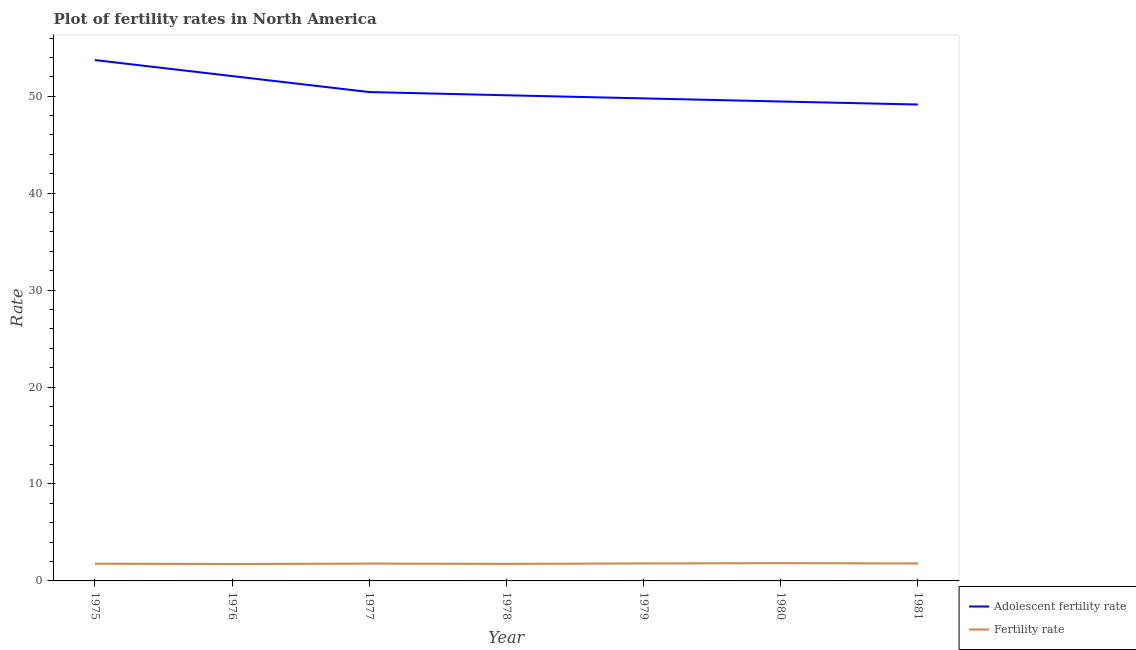Is the number of lines equal to the number of legend labels?
Offer a very short reply. Yes. What is the adolescent fertility rate in 1977?
Offer a terse response. 50.43. Across all years, what is the maximum adolescent fertility rate?
Offer a terse response. 53.72. Across all years, what is the minimum fertility rate?
Provide a short and direct response. 1.74. In which year was the adolescent fertility rate minimum?
Your response must be concise. 1981. What is the total fertility rate in the graph?
Offer a terse response. 12.51. What is the difference between the adolescent fertility rate in 1976 and that in 1977?
Provide a short and direct response. 1.65. What is the difference between the adolescent fertility rate in 1975 and the fertility rate in 1977?
Offer a terse response. 51.93. What is the average fertility rate per year?
Your response must be concise. 1.79. In the year 1981, what is the difference between the adolescent fertility rate and fertility rate?
Provide a short and direct response. 47.34. In how many years, is the adolescent fertility rate greater than 8?
Keep it short and to the point. 7. What is the ratio of the adolescent fertility rate in 1978 to that in 1979?
Offer a very short reply. 1.01. Is the difference between the adolescent fertility rate in 1978 and 1979 greater than the difference between the fertility rate in 1978 and 1979?
Keep it short and to the point. Yes. What is the difference between the highest and the second highest fertility rate?
Ensure brevity in your answer.  0.03. What is the difference between the highest and the lowest fertility rate?
Your response must be concise. 0.09. How many lines are there?
Give a very brief answer. 2. What is the difference between two consecutive major ticks on the Y-axis?
Your response must be concise. 10. Are the values on the major ticks of Y-axis written in scientific E-notation?
Offer a terse response. No. What is the title of the graph?
Keep it short and to the point. Plot of fertility rates in North America. Does "Register a property" appear as one of the legend labels in the graph?
Keep it short and to the point. No. What is the label or title of the X-axis?
Provide a short and direct response. Year. What is the label or title of the Y-axis?
Your answer should be very brief. Rate. What is the Rate of Adolescent fertility rate in 1975?
Ensure brevity in your answer.  53.72. What is the Rate of Fertility rate in 1975?
Give a very brief answer. 1.78. What is the Rate in Adolescent fertility rate in 1976?
Your answer should be very brief. 52.07. What is the Rate in Fertility rate in 1976?
Offer a very short reply. 1.74. What is the Rate in Adolescent fertility rate in 1977?
Make the answer very short. 50.43. What is the Rate of Fertility rate in 1977?
Offer a terse response. 1.79. What is the Rate of Adolescent fertility rate in 1978?
Keep it short and to the point. 50.09. What is the Rate in Fertility rate in 1978?
Keep it short and to the point. 1.76. What is the Rate in Adolescent fertility rate in 1979?
Ensure brevity in your answer.  49.77. What is the Rate of Fertility rate in 1979?
Provide a succinct answer. 1.8. What is the Rate of Adolescent fertility rate in 1980?
Your response must be concise. 49.45. What is the Rate in Fertility rate in 1980?
Keep it short and to the point. 1.83. What is the Rate in Adolescent fertility rate in 1981?
Give a very brief answer. 49.14. What is the Rate of Fertility rate in 1981?
Give a very brief answer. 1.8. Across all years, what is the maximum Rate of Adolescent fertility rate?
Ensure brevity in your answer.  53.72. Across all years, what is the maximum Rate of Fertility rate?
Your response must be concise. 1.83. Across all years, what is the minimum Rate of Adolescent fertility rate?
Offer a terse response. 49.14. Across all years, what is the minimum Rate of Fertility rate?
Provide a succinct answer. 1.74. What is the total Rate of Adolescent fertility rate in the graph?
Keep it short and to the point. 354.68. What is the total Rate in Fertility rate in the graph?
Offer a very short reply. 12.51. What is the difference between the Rate in Adolescent fertility rate in 1975 and that in 1976?
Offer a very short reply. 1.65. What is the difference between the Rate in Fertility rate in 1975 and that in 1976?
Your answer should be compact. 0.04. What is the difference between the Rate of Adolescent fertility rate in 1975 and that in 1977?
Offer a terse response. 3.3. What is the difference between the Rate of Fertility rate in 1975 and that in 1977?
Your answer should be compact. -0.01. What is the difference between the Rate of Adolescent fertility rate in 1975 and that in 1978?
Offer a very short reply. 3.63. What is the difference between the Rate in Fertility rate in 1975 and that in 1978?
Give a very brief answer. 0.02. What is the difference between the Rate in Adolescent fertility rate in 1975 and that in 1979?
Give a very brief answer. 3.95. What is the difference between the Rate of Fertility rate in 1975 and that in 1979?
Give a very brief answer. -0.02. What is the difference between the Rate of Adolescent fertility rate in 1975 and that in 1980?
Provide a succinct answer. 4.27. What is the difference between the Rate of Fertility rate in 1975 and that in 1980?
Your response must be concise. -0.05. What is the difference between the Rate of Adolescent fertility rate in 1975 and that in 1981?
Your answer should be compact. 4.58. What is the difference between the Rate in Fertility rate in 1975 and that in 1981?
Make the answer very short. -0.02. What is the difference between the Rate in Adolescent fertility rate in 1976 and that in 1977?
Ensure brevity in your answer.  1.65. What is the difference between the Rate of Fertility rate in 1976 and that in 1977?
Offer a terse response. -0.05. What is the difference between the Rate in Adolescent fertility rate in 1976 and that in 1978?
Provide a short and direct response. 1.98. What is the difference between the Rate of Fertility rate in 1976 and that in 1978?
Ensure brevity in your answer.  -0.02. What is the difference between the Rate in Adolescent fertility rate in 1976 and that in 1979?
Offer a terse response. 2.3. What is the difference between the Rate of Fertility rate in 1976 and that in 1979?
Ensure brevity in your answer.  -0.06. What is the difference between the Rate in Adolescent fertility rate in 1976 and that in 1980?
Provide a succinct answer. 2.62. What is the difference between the Rate of Fertility rate in 1976 and that in 1980?
Your response must be concise. -0.09. What is the difference between the Rate in Adolescent fertility rate in 1976 and that in 1981?
Your answer should be very brief. 2.94. What is the difference between the Rate of Fertility rate in 1976 and that in 1981?
Offer a very short reply. -0.06. What is the difference between the Rate in Adolescent fertility rate in 1977 and that in 1978?
Make the answer very short. 0.33. What is the difference between the Rate of Fertility rate in 1977 and that in 1978?
Offer a very short reply. 0.03. What is the difference between the Rate of Adolescent fertility rate in 1977 and that in 1979?
Offer a very short reply. 0.65. What is the difference between the Rate in Fertility rate in 1977 and that in 1979?
Give a very brief answer. -0.01. What is the difference between the Rate of Fertility rate in 1977 and that in 1980?
Your response must be concise. -0.04. What is the difference between the Rate in Adolescent fertility rate in 1977 and that in 1981?
Provide a succinct answer. 1.29. What is the difference between the Rate of Fertility rate in 1977 and that in 1981?
Provide a succinct answer. -0.01. What is the difference between the Rate in Adolescent fertility rate in 1978 and that in 1979?
Your answer should be very brief. 0.32. What is the difference between the Rate in Fertility rate in 1978 and that in 1979?
Provide a short and direct response. -0.04. What is the difference between the Rate in Adolescent fertility rate in 1978 and that in 1980?
Your response must be concise. 0.64. What is the difference between the Rate in Fertility rate in 1978 and that in 1980?
Make the answer very short. -0.07. What is the difference between the Rate of Adolescent fertility rate in 1978 and that in 1981?
Provide a short and direct response. 0.96. What is the difference between the Rate in Fertility rate in 1978 and that in 1981?
Your answer should be very brief. -0.04. What is the difference between the Rate of Adolescent fertility rate in 1979 and that in 1980?
Provide a short and direct response. 0.32. What is the difference between the Rate in Fertility rate in 1979 and that in 1980?
Make the answer very short. -0.03. What is the difference between the Rate of Adolescent fertility rate in 1979 and that in 1981?
Offer a terse response. 0.63. What is the difference between the Rate in Fertility rate in 1979 and that in 1981?
Offer a very short reply. 0. What is the difference between the Rate of Adolescent fertility rate in 1980 and that in 1981?
Give a very brief answer. 0.31. What is the difference between the Rate in Fertility rate in 1980 and that in 1981?
Offer a very short reply. 0.03. What is the difference between the Rate in Adolescent fertility rate in 1975 and the Rate in Fertility rate in 1976?
Ensure brevity in your answer.  51.98. What is the difference between the Rate of Adolescent fertility rate in 1975 and the Rate of Fertility rate in 1977?
Your answer should be compact. 51.93. What is the difference between the Rate of Adolescent fertility rate in 1975 and the Rate of Fertility rate in 1978?
Provide a short and direct response. 51.96. What is the difference between the Rate of Adolescent fertility rate in 1975 and the Rate of Fertility rate in 1979?
Provide a short and direct response. 51.92. What is the difference between the Rate in Adolescent fertility rate in 1975 and the Rate in Fertility rate in 1980?
Provide a succinct answer. 51.89. What is the difference between the Rate of Adolescent fertility rate in 1975 and the Rate of Fertility rate in 1981?
Provide a short and direct response. 51.92. What is the difference between the Rate in Adolescent fertility rate in 1976 and the Rate in Fertility rate in 1977?
Your answer should be very brief. 50.29. What is the difference between the Rate in Adolescent fertility rate in 1976 and the Rate in Fertility rate in 1978?
Ensure brevity in your answer.  50.31. What is the difference between the Rate in Adolescent fertility rate in 1976 and the Rate in Fertility rate in 1979?
Ensure brevity in your answer.  50.27. What is the difference between the Rate in Adolescent fertility rate in 1976 and the Rate in Fertility rate in 1980?
Your response must be concise. 50.24. What is the difference between the Rate of Adolescent fertility rate in 1976 and the Rate of Fertility rate in 1981?
Make the answer very short. 50.27. What is the difference between the Rate in Adolescent fertility rate in 1977 and the Rate in Fertility rate in 1978?
Make the answer very short. 48.66. What is the difference between the Rate of Adolescent fertility rate in 1977 and the Rate of Fertility rate in 1979?
Keep it short and to the point. 48.62. What is the difference between the Rate of Adolescent fertility rate in 1977 and the Rate of Fertility rate in 1980?
Your response must be concise. 48.6. What is the difference between the Rate of Adolescent fertility rate in 1977 and the Rate of Fertility rate in 1981?
Provide a short and direct response. 48.62. What is the difference between the Rate in Adolescent fertility rate in 1978 and the Rate in Fertility rate in 1979?
Your answer should be compact. 48.29. What is the difference between the Rate in Adolescent fertility rate in 1978 and the Rate in Fertility rate in 1980?
Your response must be concise. 48.26. What is the difference between the Rate in Adolescent fertility rate in 1978 and the Rate in Fertility rate in 1981?
Your answer should be compact. 48.29. What is the difference between the Rate of Adolescent fertility rate in 1979 and the Rate of Fertility rate in 1980?
Offer a very short reply. 47.94. What is the difference between the Rate of Adolescent fertility rate in 1979 and the Rate of Fertility rate in 1981?
Provide a short and direct response. 47.97. What is the difference between the Rate of Adolescent fertility rate in 1980 and the Rate of Fertility rate in 1981?
Offer a very short reply. 47.65. What is the average Rate of Adolescent fertility rate per year?
Provide a short and direct response. 50.67. What is the average Rate of Fertility rate per year?
Your answer should be very brief. 1.79. In the year 1975, what is the difference between the Rate of Adolescent fertility rate and Rate of Fertility rate?
Make the answer very short. 51.94. In the year 1976, what is the difference between the Rate of Adolescent fertility rate and Rate of Fertility rate?
Offer a very short reply. 50.33. In the year 1977, what is the difference between the Rate of Adolescent fertility rate and Rate of Fertility rate?
Offer a very short reply. 48.64. In the year 1978, what is the difference between the Rate in Adolescent fertility rate and Rate in Fertility rate?
Keep it short and to the point. 48.33. In the year 1979, what is the difference between the Rate in Adolescent fertility rate and Rate in Fertility rate?
Your answer should be compact. 47.97. In the year 1980, what is the difference between the Rate in Adolescent fertility rate and Rate in Fertility rate?
Give a very brief answer. 47.62. In the year 1981, what is the difference between the Rate in Adolescent fertility rate and Rate in Fertility rate?
Ensure brevity in your answer.  47.34. What is the ratio of the Rate of Adolescent fertility rate in 1975 to that in 1976?
Provide a short and direct response. 1.03. What is the ratio of the Rate of Fertility rate in 1975 to that in 1976?
Your response must be concise. 1.02. What is the ratio of the Rate in Adolescent fertility rate in 1975 to that in 1977?
Ensure brevity in your answer.  1.07. What is the ratio of the Rate of Fertility rate in 1975 to that in 1977?
Keep it short and to the point. 0.99. What is the ratio of the Rate in Adolescent fertility rate in 1975 to that in 1978?
Provide a succinct answer. 1.07. What is the ratio of the Rate in Fertility rate in 1975 to that in 1978?
Make the answer very short. 1.01. What is the ratio of the Rate in Adolescent fertility rate in 1975 to that in 1979?
Your response must be concise. 1.08. What is the ratio of the Rate in Fertility rate in 1975 to that in 1979?
Provide a short and direct response. 0.99. What is the ratio of the Rate in Adolescent fertility rate in 1975 to that in 1980?
Provide a succinct answer. 1.09. What is the ratio of the Rate in Fertility rate in 1975 to that in 1980?
Your answer should be compact. 0.97. What is the ratio of the Rate in Adolescent fertility rate in 1975 to that in 1981?
Your answer should be compact. 1.09. What is the ratio of the Rate of Fertility rate in 1975 to that in 1981?
Keep it short and to the point. 0.99. What is the ratio of the Rate of Adolescent fertility rate in 1976 to that in 1977?
Provide a short and direct response. 1.03. What is the ratio of the Rate of Fertility rate in 1976 to that in 1977?
Provide a short and direct response. 0.97. What is the ratio of the Rate in Adolescent fertility rate in 1976 to that in 1978?
Give a very brief answer. 1.04. What is the ratio of the Rate in Adolescent fertility rate in 1976 to that in 1979?
Provide a short and direct response. 1.05. What is the ratio of the Rate of Fertility rate in 1976 to that in 1979?
Give a very brief answer. 0.97. What is the ratio of the Rate in Adolescent fertility rate in 1976 to that in 1980?
Your answer should be very brief. 1.05. What is the ratio of the Rate in Fertility rate in 1976 to that in 1980?
Your answer should be very brief. 0.95. What is the ratio of the Rate in Adolescent fertility rate in 1976 to that in 1981?
Offer a very short reply. 1.06. What is the ratio of the Rate of Fertility rate in 1976 to that in 1981?
Make the answer very short. 0.97. What is the ratio of the Rate of Adolescent fertility rate in 1977 to that in 1978?
Offer a terse response. 1.01. What is the ratio of the Rate of Fertility rate in 1977 to that in 1978?
Give a very brief answer. 1.02. What is the ratio of the Rate of Adolescent fertility rate in 1977 to that in 1979?
Provide a succinct answer. 1.01. What is the ratio of the Rate of Adolescent fertility rate in 1977 to that in 1980?
Make the answer very short. 1.02. What is the ratio of the Rate in Fertility rate in 1977 to that in 1980?
Make the answer very short. 0.98. What is the ratio of the Rate in Adolescent fertility rate in 1977 to that in 1981?
Provide a short and direct response. 1.03. What is the ratio of the Rate of Fertility rate in 1977 to that in 1981?
Provide a short and direct response. 0.99. What is the ratio of the Rate of Fertility rate in 1978 to that in 1979?
Keep it short and to the point. 0.98. What is the ratio of the Rate of Fertility rate in 1978 to that in 1980?
Your response must be concise. 0.96. What is the ratio of the Rate of Adolescent fertility rate in 1978 to that in 1981?
Offer a terse response. 1.02. What is the ratio of the Rate in Fertility rate in 1978 to that in 1981?
Offer a very short reply. 0.98. What is the ratio of the Rate of Adolescent fertility rate in 1979 to that in 1981?
Offer a terse response. 1.01. What is the ratio of the Rate in Fertility rate in 1979 to that in 1981?
Make the answer very short. 1. What is the difference between the highest and the second highest Rate of Adolescent fertility rate?
Give a very brief answer. 1.65. What is the difference between the highest and the second highest Rate of Fertility rate?
Your answer should be compact. 0.03. What is the difference between the highest and the lowest Rate in Adolescent fertility rate?
Your response must be concise. 4.58. What is the difference between the highest and the lowest Rate of Fertility rate?
Your response must be concise. 0.09. 